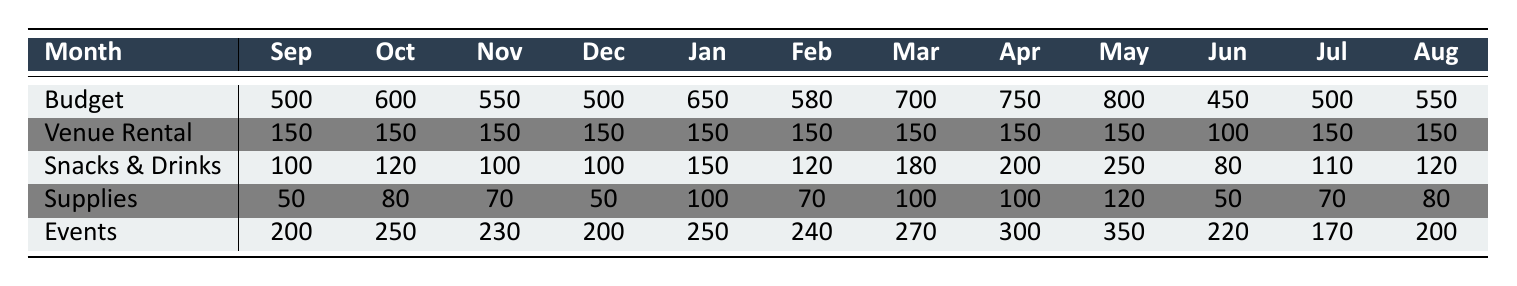What is the total budget for May? The table lists the budget for each month, and in the row for Budget under May, it shows a total budget of 800.
Answer: 800 How much was spent on snacks and drinks in February? In the table, under the Snacks & Drinks row for February, the expenditure is listed as 120.
Answer: 120 What is the average monthly budget across all months? To find the average, sum all the total budgets (500 + 600 + 550 + 500 + 650 + 580 + 700 + 750 + 800 + 450 + 500 + 550 = 6,030) and divide by 12 months. The average is 6,030 / 12 = 502.5.
Answer: 502.5 Did the club spend more on events in March than in January? Looking at the Events row, in March, the spending is 270 and in January it is 250. Since 270 is greater than 250, the answer is yes.
Answer: Yes What was the total expense for venue rental for the entire academic year? To find the total expense on venue rentals, we add the amounts in the Venue Rental row across all months (150*10 + 100*1 = 1,500 + 100 = 1,600).
Answer: 1,600 In which month did the club spend the least on snacks and drinks? Checking the Snacks & Drinks row, the smallest amount listed is 80 in June.
Answer: June What is the difference between the total budget for April and the actual expenses on events in April? The budget for April is 750 and the expenses on events are 300, so the difference is 750 - 300 = 450.
Answer: 450 How many months had a total budget greater than 600? Looking at the Budget row, the months with budgets greater than 600 are October (600), January (650), March (700), April (750), and May (800). Count these months, which totals 5.
Answer: 5 In which month was the expenditure on supplies the highest? Looking at the Supplies row, the highest expenditure is 120, which is in May.
Answer: May Was the total expense on snacks and drinks during the academic year greater than 1,400? To find this, add the amounts of Snacks & Drinks across all months (100 + 120 + 100 + 100 + 150 + 120 + 180 + 200 + 250 + 80 + 110 + 120 = 1,610). Since 1,610 is greater than 1,400, the answer is yes.
Answer: Yes 